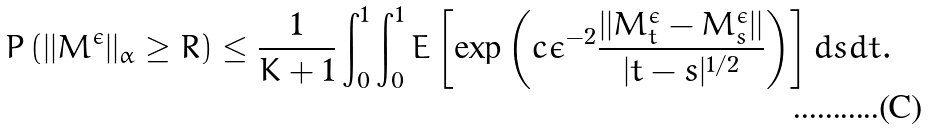Convert formula to latex. <formula><loc_0><loc_0><loc_500><loc_500>P \left ( | | M ^ { \epsilon } | | _ { \alpha } \geq R \right ) \leq \frac { 1 } { K + 1 } \int _ { 0 } ^ { 1 } \int _ { 0 } ^ { 1 } E \left [ \exp \left ( c \epsilon ^ { - 2 } \frac { | | M ^ { \epsilon } _ { t } - M ^ { \epsilon } _ { s } | | } { | t - s | ^ { 1 / 2 } } \right ) \right ] d s d t .</formula> 